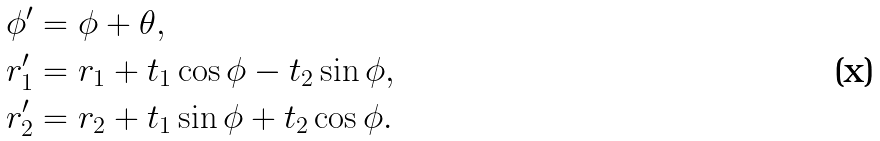<formula> <loc_0><loc_0><loc_500><loc_500>\phi ^ { \prime } & = \phi + \theta , \\ r ^ { \prime } _ { 1 } & = r _ { 1 } + t _ { 1 } \cos \phi - t _ { 2 } \sin \phi , \\ r ^ { \prime } _ { 2 } & = r _ { 2 } + t _ { 1 } \sin \phi + t _ { 2 } \cos \phi .</formula> 